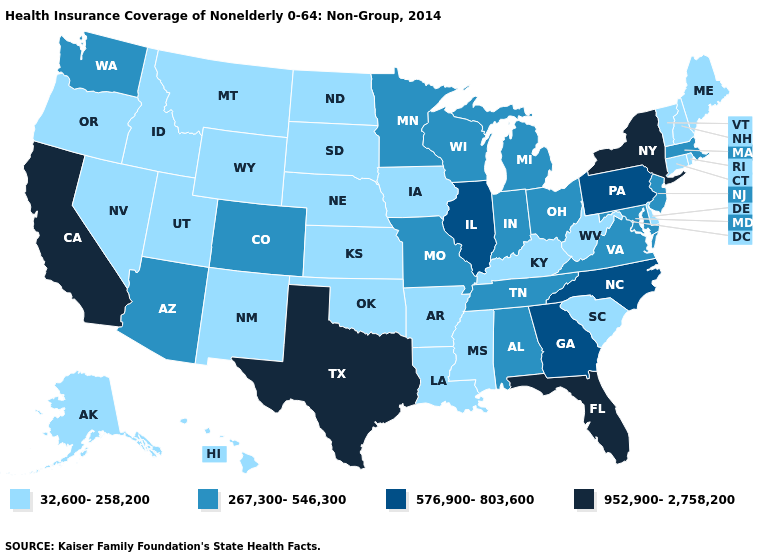Name the states that have a value in the range 952,900-2,758,200?
Answer briefly. California, Florida, New York, Texas. Which states have the highest value in the USA?
Quick response, please. California, Florida, New York, Texas. How many symbols are there in the legend?
Short answer required. 4. What is the value of California?
Keep it brief. 952,900-2,758,200. Which states have the lowest value in the Northeast?
Quick response, please. Connecticut, Maine, New Hampshire, Rhode Island, Vermont. Among the states that border Maryland , which have the highest value?
Quick response, please. Pennsylvania. Is the legend a continuous bar?
Concise answer only. No. What is the highest value in the Northeast ?
Quick response, please. 952,900-2,758,200. Among the states that border Iowa , which have the highest value?
Be succinct. Illinois. What is the lowest value in the USA?
Keep it brief. 32,600-258,200. How many symbols are there in the legend?
Keep it brief. 4. What is the value of Washington?
Answer briefly. 267,300-546,300. Does the map have missing data?
Quick response, please. No. What is the value of North Dakota?
Quick response, please. 32,600-258,200. 